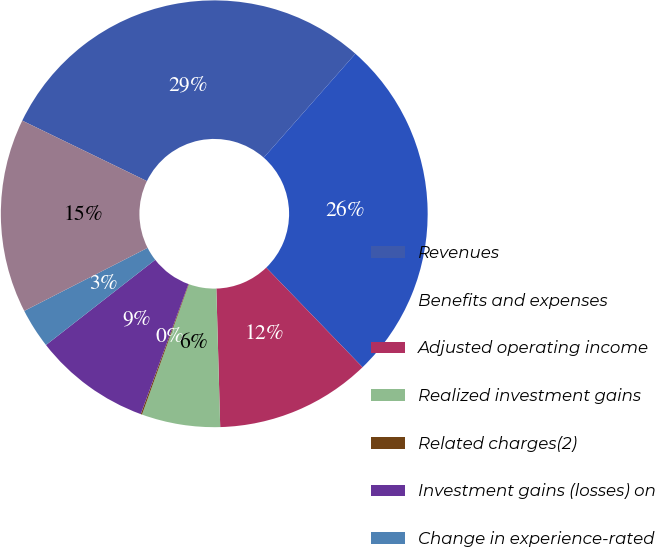Convert chart to OTSL. <chart><loc_0><loc_0><loc_500><loc_500><pie_chart><fcel>Revenues<fcel>Benefits and expenses<fcel>Adjusted operating income<fcel>Realized investment gains<fcel>Related charges(2)<fcel>Investment gains (losses) on<fcel>Change in experience-rated<fcel>Income from continuing<nl><fcel>29.31%<fcel>26.27%<fcel>11.78%<fcel>5.94%<fcel>0.1%<fcel>8.86%<fcel>3.02%<fcel>14.71%<nl></chart> 